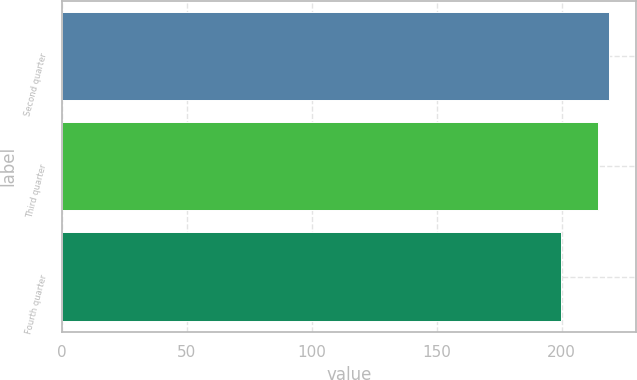Convert chart to OTSL. <chart><loc_0><loc_0><loc_500><loc_500><bar_chart><fcel>Second quarter<fcel>Third quarter<fcel>Fourth quarter<nl><fcel>218.77<fcel>214.61<fcel>199.9<nl></chart> 